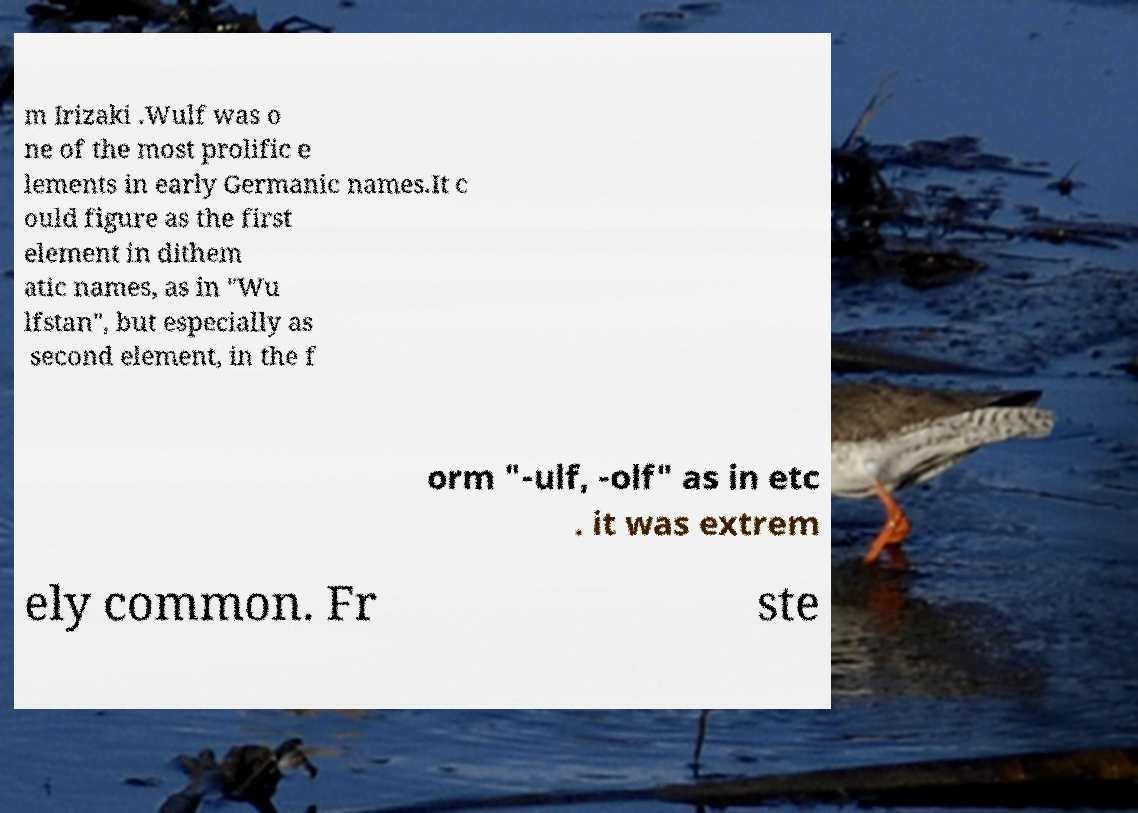Please read and relay the text visible in this image. What does it say? m Irizaki .Wulf was o ne of the most prolific e lements in early Germanic names.It c ould figure as the first element in dithem atic names, as in "Wu lfstan", but especially as second element, in the f orm "-ulf, -olf" as in etc . it was extrem ely common. Fr ste 